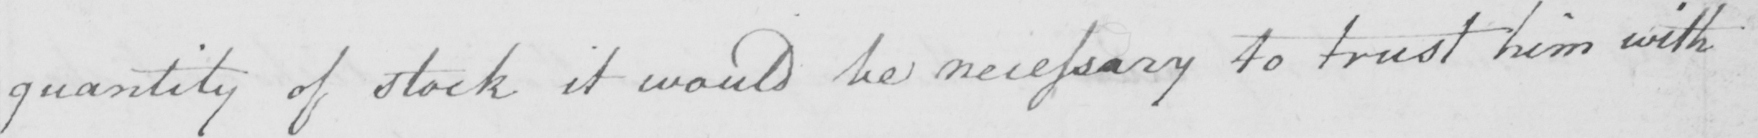Can you tell me what this handwritten text says? quantity of stock it would be necessary to trust him with 